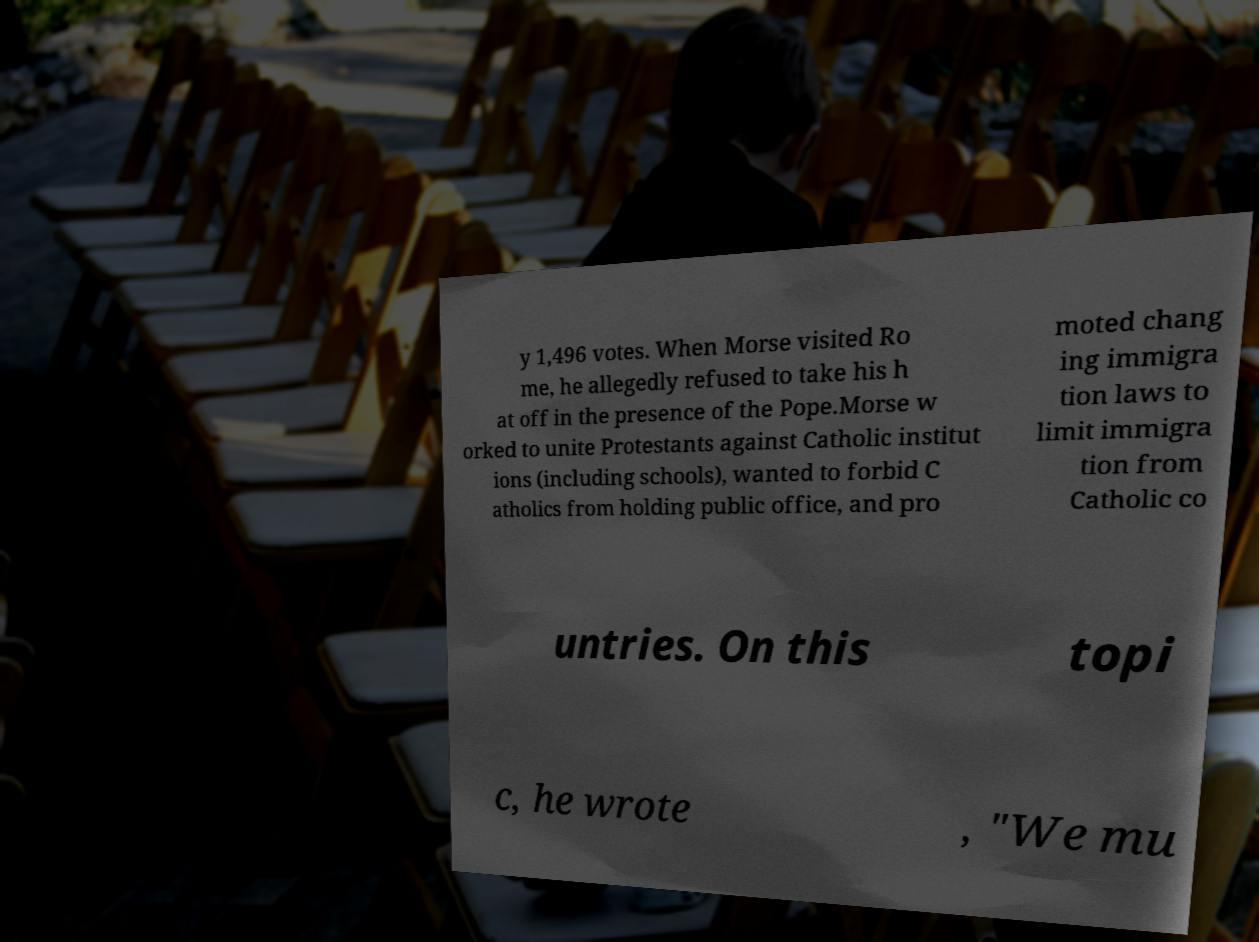For documentation purposes, I need the text within this image transcribed. Could you provide that? y 1,496 votes. When Morse visited Ro me, he allegedly refused to take his h at off in the presence of the Pope.Morse w orked to unite Protestants against Catholic institut ions (including schools), wanted to forbid C atholics from holding public office, and pro moted chang ing immigra tion laws to limit immigra tion from Catholic co untries. On this topi c, he wrote , "We mu 